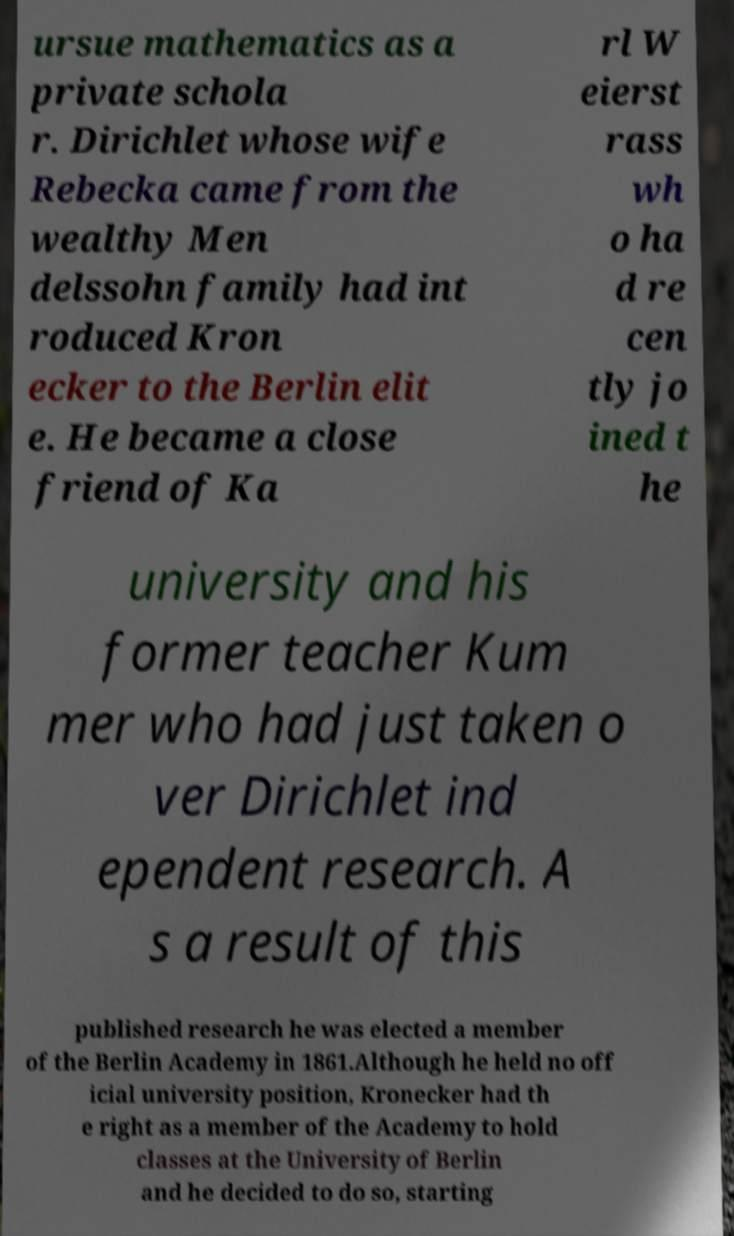There's text embedded in this image that I need extracted. Can you transcribe it verbatim? ursue mathematics as a private schola r. Dirichlet whose wife Rebecka came from the wealthy Men delssohn family had int roduced Kron ecker to the Berlin elit e. He became a close friend of Ka rl W eierst rass wh o ha d re cen tly jo ined t he university and his former teacher Kum mer who had just taken o ver Dirichlet ind ependent research. A s a result of this published research he was elected a member of the Berlin Academy in 1861.Although he held no off icial university position, Kronecker had th e right as a member of the Academy to hold classes at the University of Berlin and he decided to do so, starting 